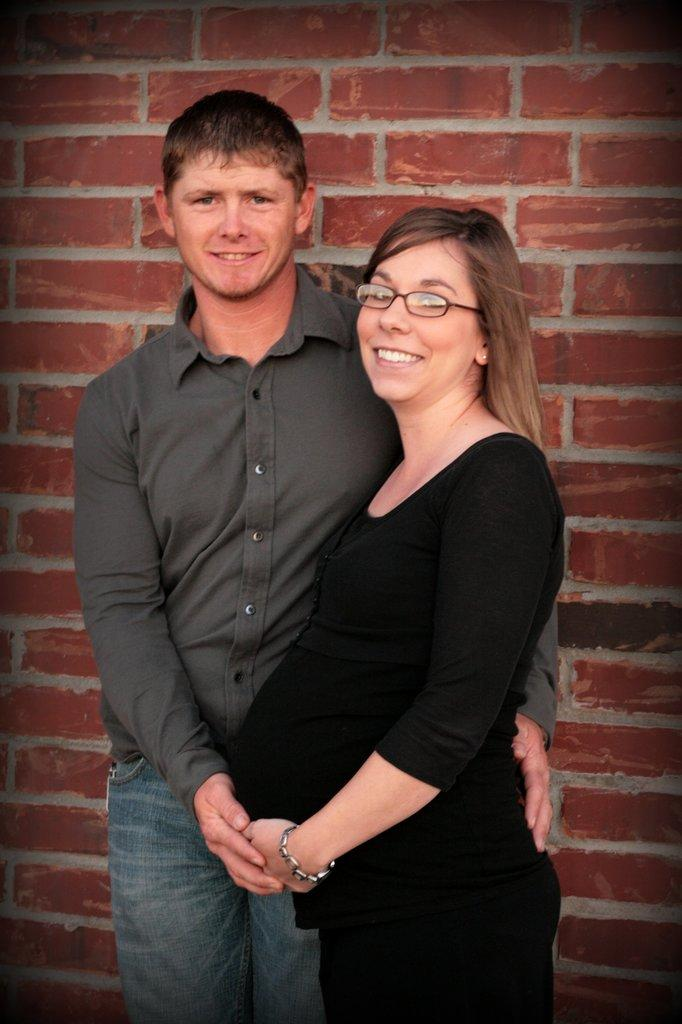Who is present in the image? There is a man and a woman in the image. What are the man and the woman doing in the image? Both the man and the woman are standing and smiling. What can be seen in the background of the image? There is a wall in the background of the image. What type of servant is standing next to the man in the image? There is no servant present in the image; it only features a man and a woman. What are the man and the woman holding in their hands in the image? The provided facts do not mention any objects being held by the man and the woman, so we cannot determine what they might be holding. 